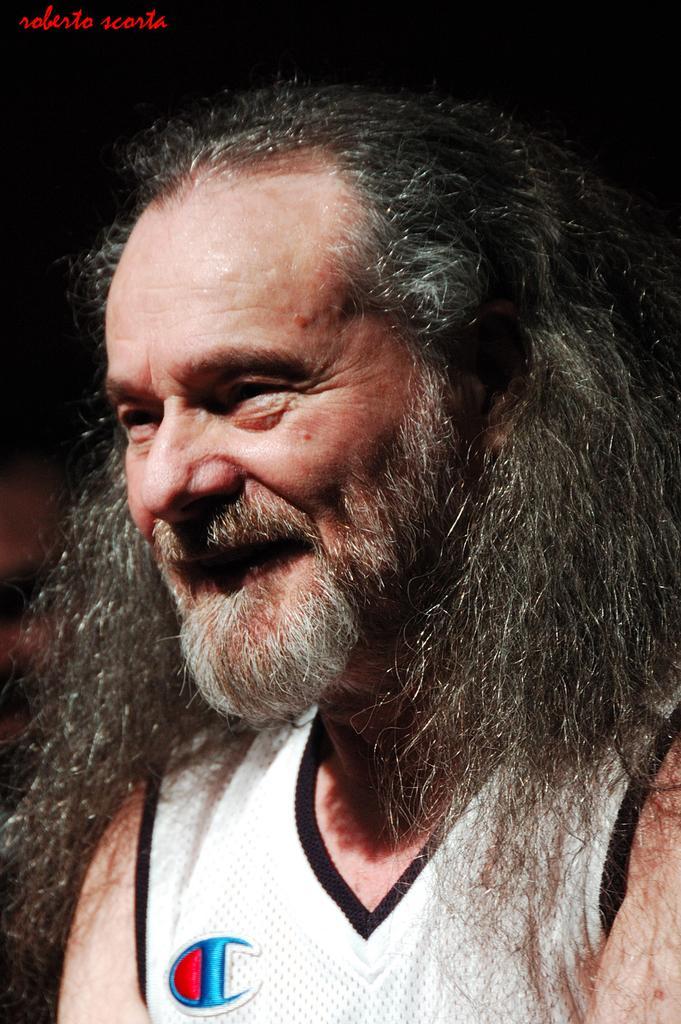How would you summarize this image in a sentence or two? In this image I can see a man and a text. This image looks like a photo frame. 